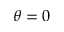<formula> <loc_0><loc_0><loc_500><loc_500>\theta = 0</formula> 